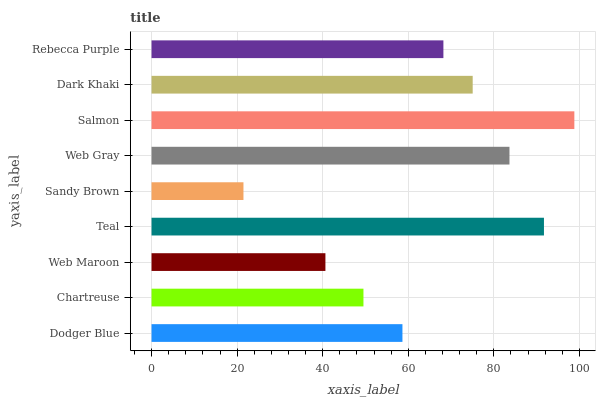Is Sandy Brown the minimum?
Answer yes or no. Yes. Is Salmon the maximum?
Answer yes or no. Yes. Is Chartreuse the minimum?
Answer yes or no. No. Is Chartreuse the maximum?
Answer yes or no. No. Is Dodger Blue greater than Chartreuse?
Answer yes or no. Yes. Is Chartreuse less than Dodger Blue?
Answer yes or no. Yes. Is Chartreuse greater than Dodger Blue?
Answer yes or no. No. Is Dodger Blue less than Chartreuse?
Answer yes or no. No. Is Rebecca Purple the high median?
Answer yes or no. Yes. Is Rebecca Purple the low median?
Answer yes or no. Yes. Is Teal the high median?
Answer yes or no. No. Is Web Gray the low median?
Answer yes or no. No. 